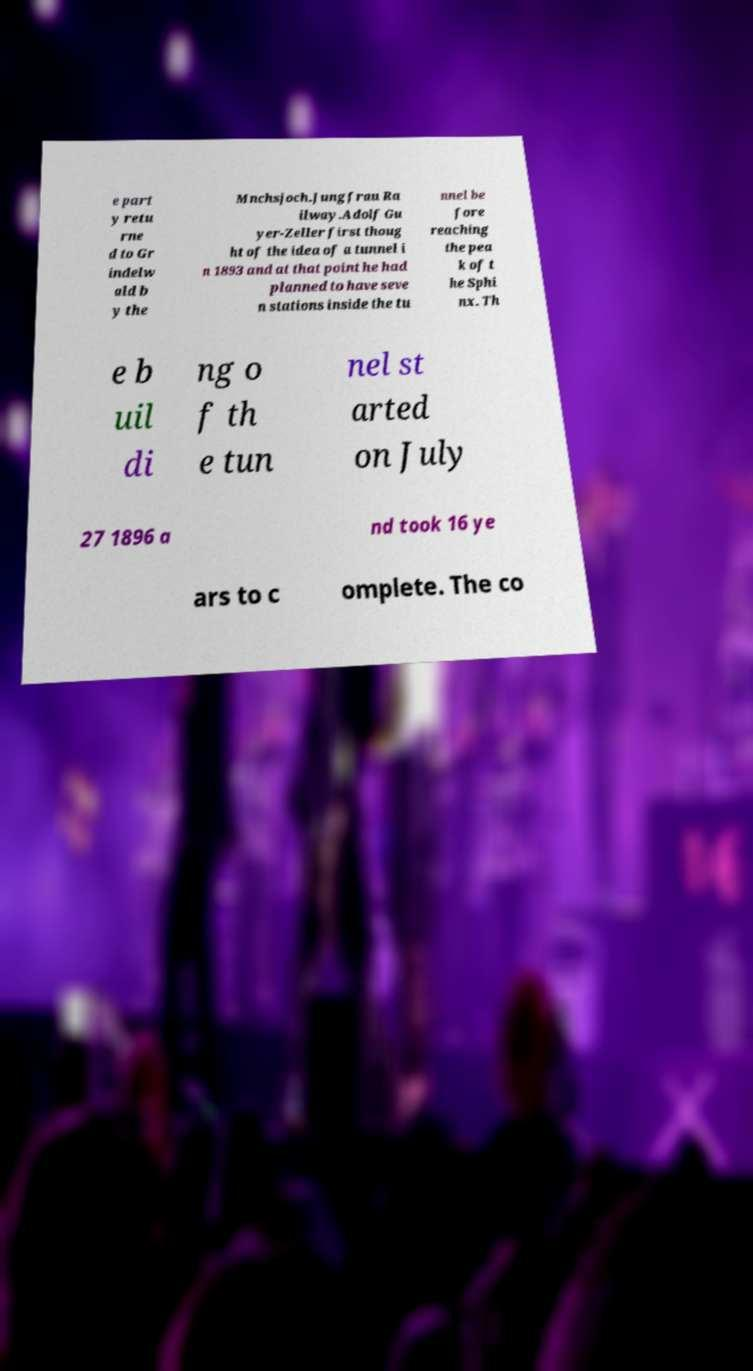I need the written content from this picture converted into text. Can you do that? e part y retu rne d to Gr indelw ald b y the Mnchsjoch.Jungfrau Ra ilway.Adolf Gu yer-Zeller first thoug ht of the idea of a tunnel i n 1893 and at that point he had planned to have seve n stations inside the tu nnel be fore reaching the pea k of t he Sphi nx. Th e b uil di ng o f th e tun nel st arted on July 27 1896 a nd took 16 ye ars to c omplete. The co 